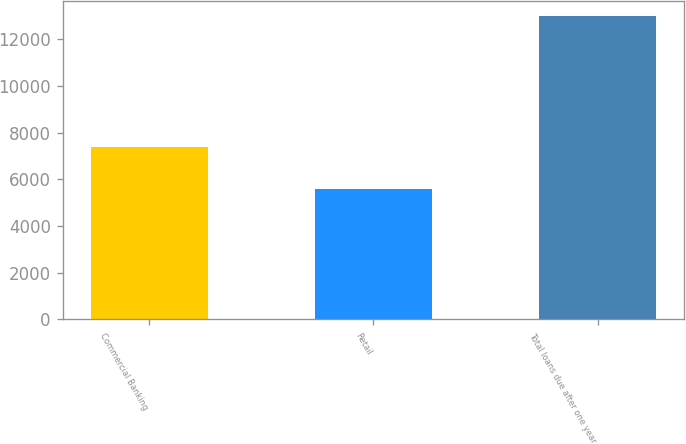Convert chart to OTSL. <chart><loc_0><loc_0><loc_500><loc_500><bar_chart><fcel>Commercial Banking<fcel>Retail<fcel>Total loans due after one year<nl><fcel>7407.2<fcel>5576.3<fcel>12983.5<nl></chart> 